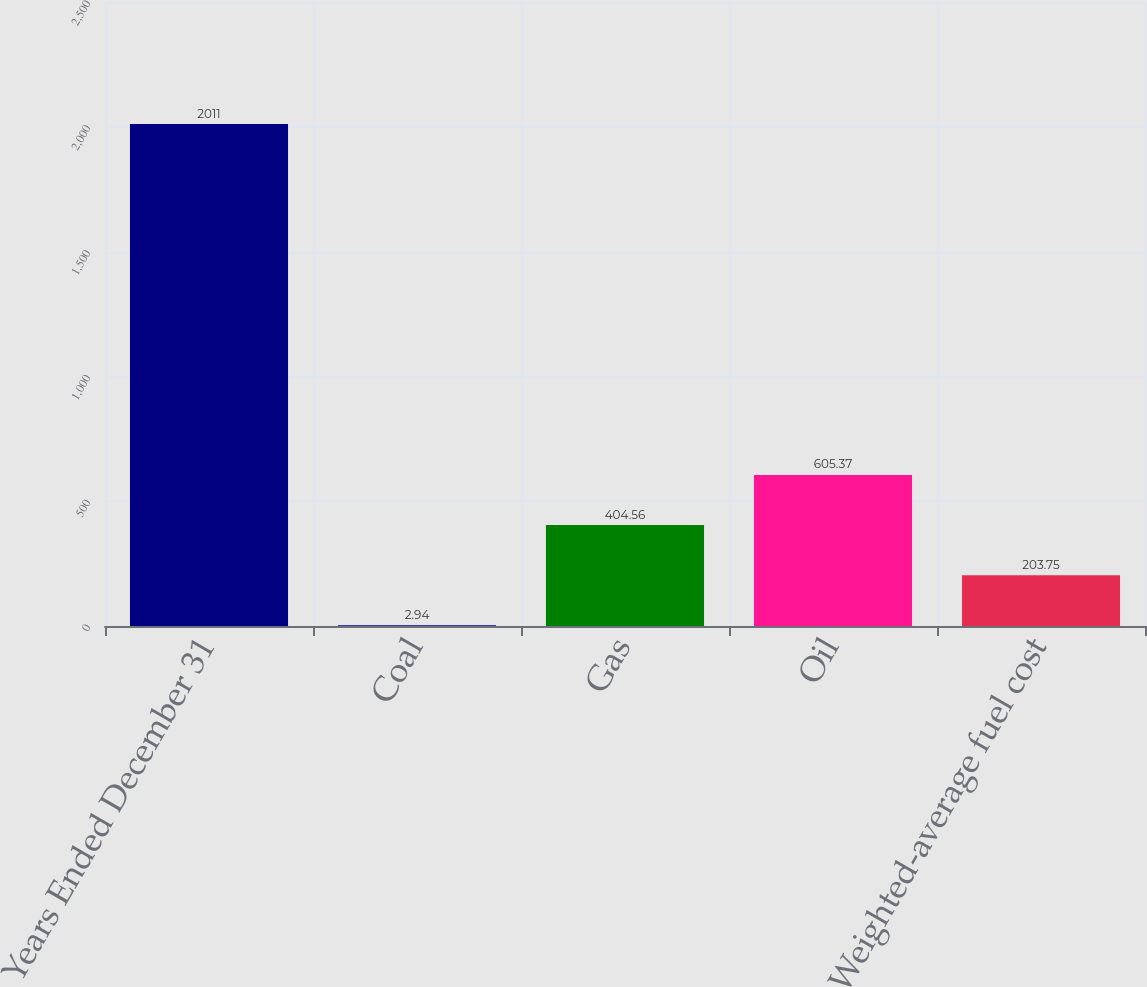Convert chart. <chart><loc_0><loc_0><loc_500><loc_500><bar_chart><fcel>Years Ended December 31<fcel>Coal<fcel>Gas<fcel>Oil<fcel>Weighted-average fuel cost<nl><fcel>2011<fcel>2.94<fcel>404.56<fcel>605.37<fcel>203.75<nl></chart> 